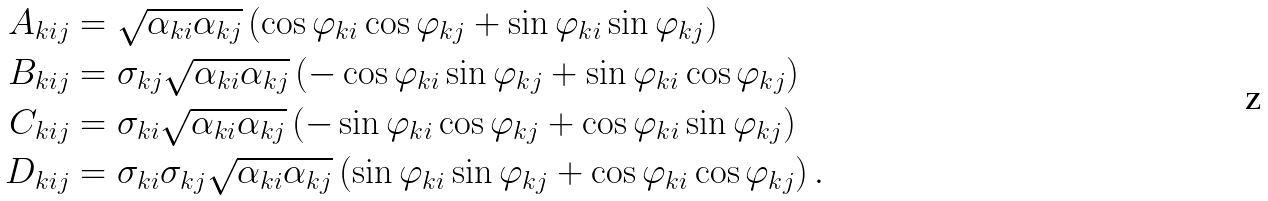Convert formula to latex. <formula><loc_0><loc_0><loc_500><loc_500>A _ { k i j } & = \sqrt { \alpha _ { k i } \alpha _ { k j } } \left ( \cos \varphi _ { k i } \cos \varphi _ { k j } + \sin \varphi _ { k i } \sin \varphi _ { k j } \right ) \\ B _ { k i j } & = \sigma _ { k j } \sqrt { \alpha _ { k i } \alpha _ { k j } } \left ( - \cos \varphi _ { k i } \sin \varphi _ { k j } + \sin \varphi _ { k i } \cos \varphi _ { k j } \right ) \\ C _ { k i j } & = \sigma _ { k i } \sqrt { \alpha _ { k i } \alpha _ { k j } } \left ( - \sin \varphi _ { k i } \cos \varphi _ { k j } + \cos \varphi _ { k i } \sin \varphi _ { k j } \right ) \\ D _ { k i j } & = \sigma _ { k i } \sigma _ { k j } \sqrt { \alpha _ { k i } \alpha _ { k j } } \left ( \sin \varphi _ { k i } \sin \varphi _ { k j } + \cos \varphi _ { k i } \cos \varphi _ { k j } \right ) .</formula> 